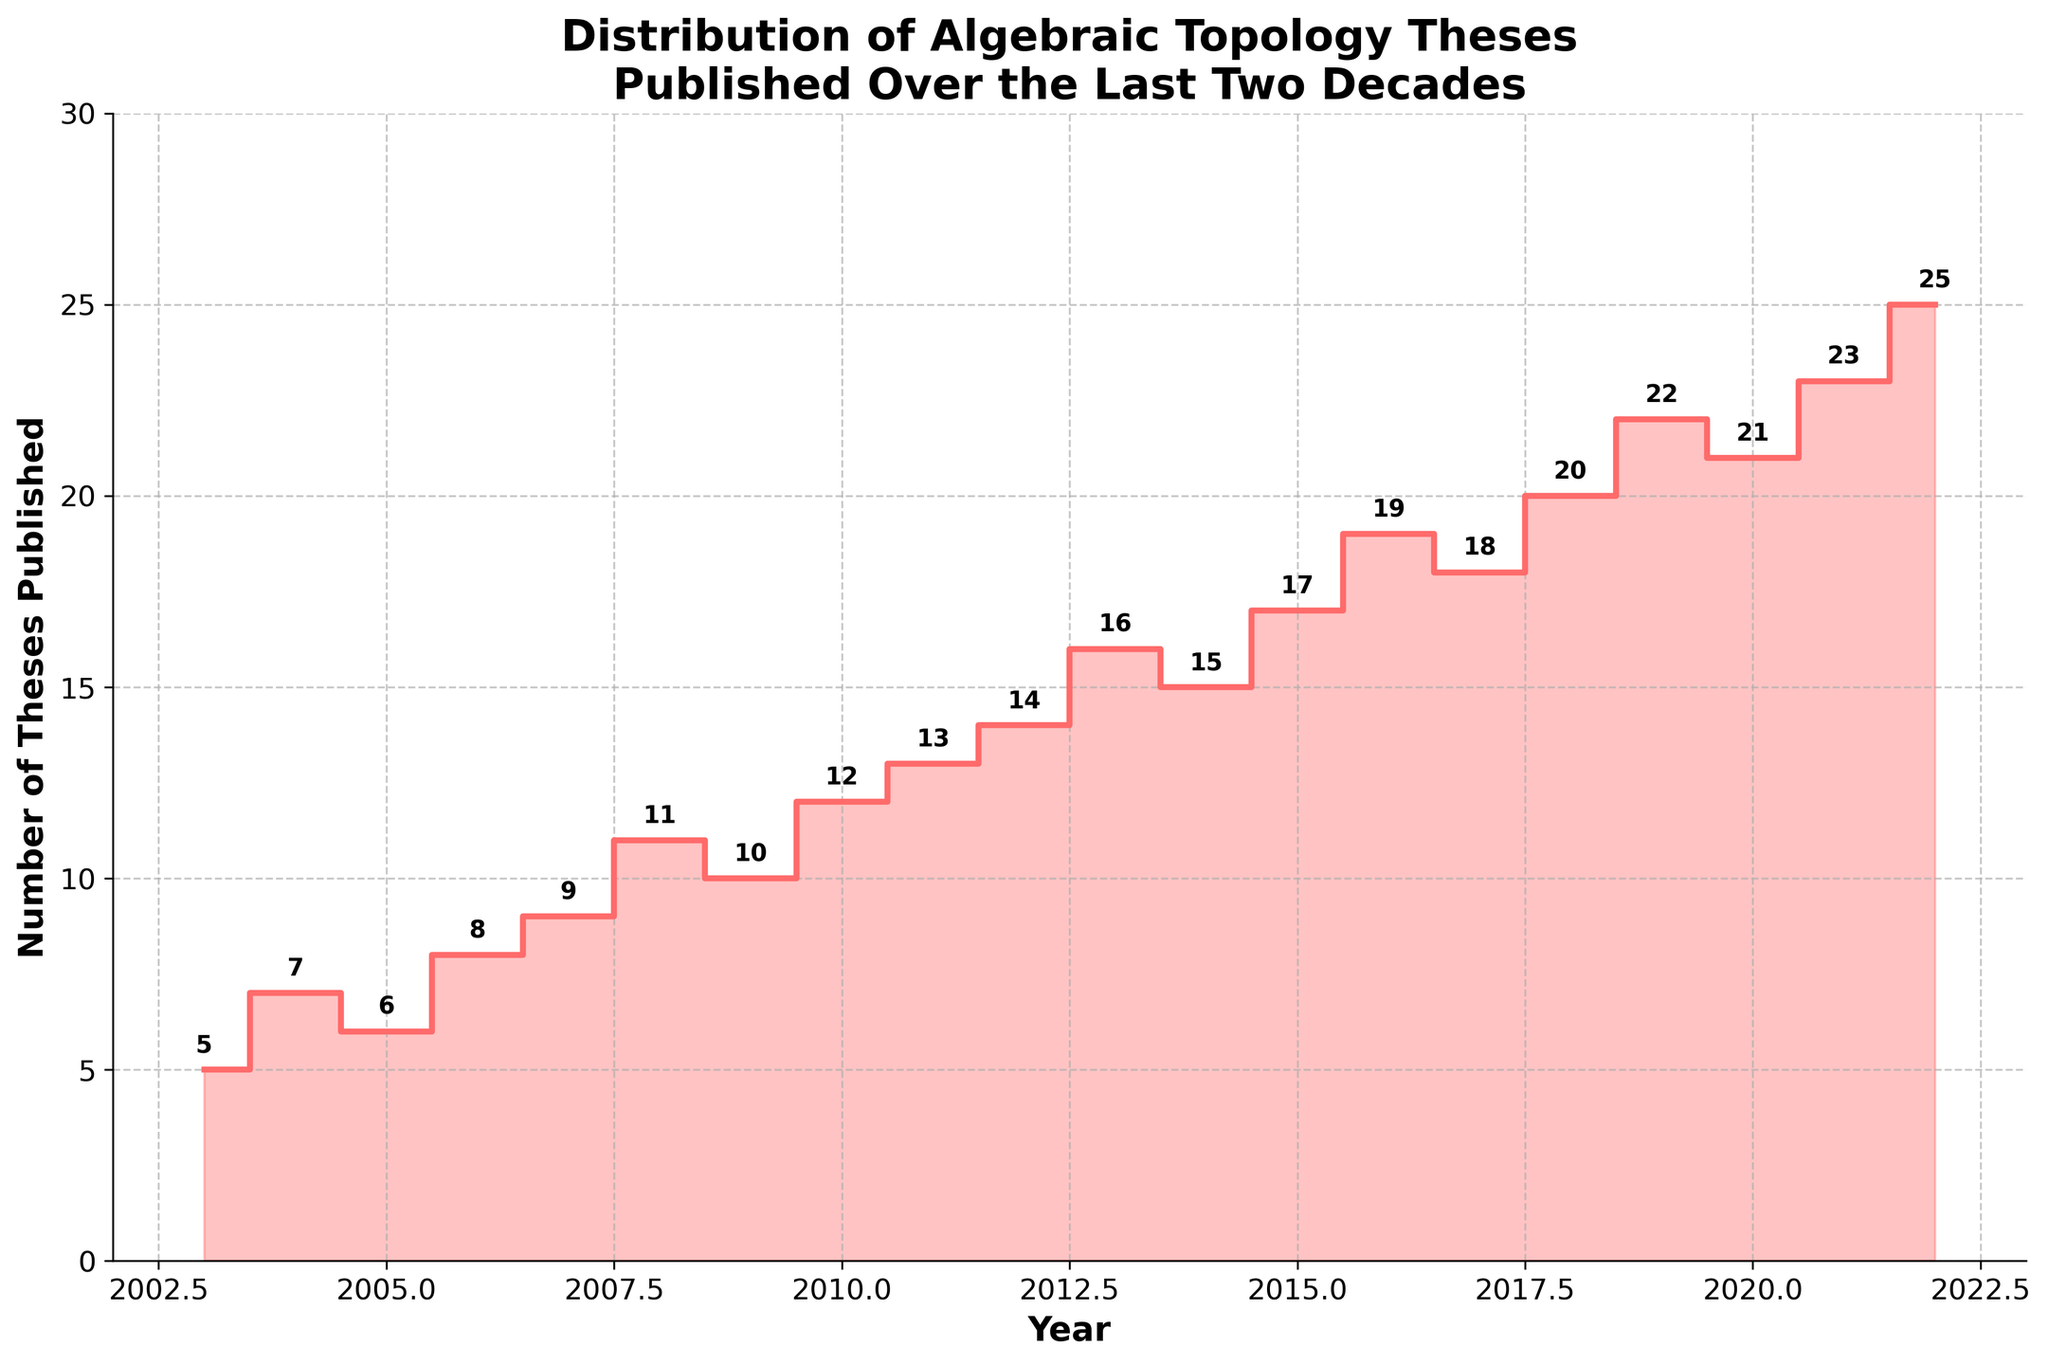What is the title of the plot? The title is located at the top of the plot and is visibly written in a larger, bold font. It reads, "Distribution of Algebraic Topology Theses Published Over the Last Two Decades".
Answer: Distribution of Algebraic Topology Theses Published Over the Last Two Decades What is the y-axis label of the plot? The y-axis label is found along the left vertical side of the plot and is written in a bold font, indicating the measure being plotted. It reads, "Number of Theses Published".
Answer: Number of Theses Published How many theses were published in 2012? Locate the x-axis value corresponding to 2012, and follow it vertically to find the step height, which is annotated at the midpoint. The annotation displays the number 14.
Answer: 14 Between which years did the number of theses published increase the most? By visually examining the lengths of the steps between each pair of consecutive years, the longest step occurs between 2018 and 2019, where the number of theses published increased by 2 (from 20 to 22).
Answer: 2018 and 2019 What was the median number of theses published per year over the two decades? To find the median, first order the numbers of theses published per year and find the middle value in the 20 data points. The sorted list: [5, 6, 7, 8, 9, 10, 11, 12, 13, 14, 15, 16, 17, 18, 19, 20, 21, 22, 23, 25]. The middle two values are 14 and 15, so the median is (14 + 15)/2 = 14.5.
Answer: 14.5 In which year did the number of theses published first exceed 20? Identify the year where the step first crosses above the horizontal line of 20 theses. This occurs in the year 2019, as indicated by the annotations.
Answer: 2019 How many theses in total were published from 2018 to 2022? Sum the number of theses published from 2018 (20) to 2022 (25). The sum is 20 + 22 + 21 + 23 + 25 = 111.
Answer: 111 Which year saw the lowest number of theses published, and what was that number? Locate the lowest step on the y-axis, which is labeled "5". The corresponding year on the x-axis is 2003.
Answer: 2003, 5 How does the trend in the number of theses published change over the two decades? The overall trend can be observed by noting how the steps generally increase from left to right, indicating a rising trend. This trend is consistently indicated by a positive slope, with some minor fluctuations.
Answer: Increasing trend 